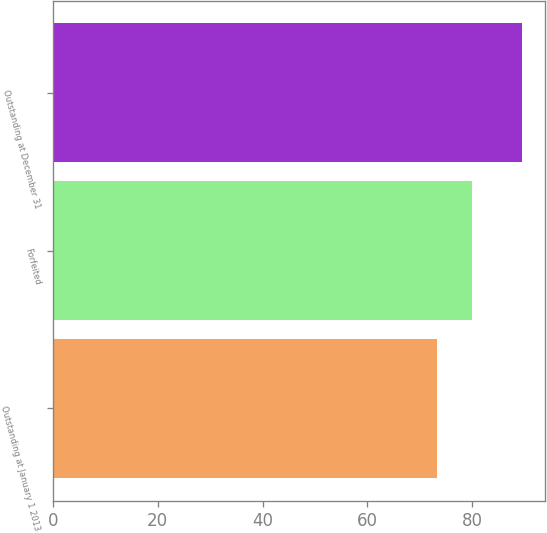Convert chart. <chart><loc_0><loc_0><loc_500><loc_500><bar_chart><fcel>Outstanding at January 1 2013<fcel>Forfeited<fcel>Outstanding at December 31<nl><fcel>73.26<fcel>79.99<fcel>89.45<nl></chart> 